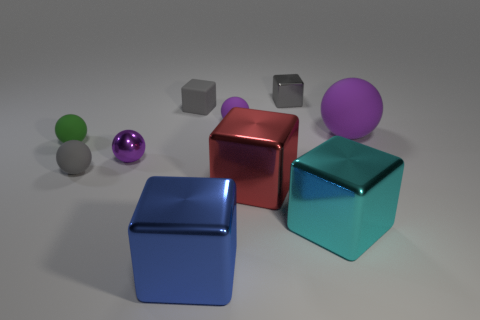Subtract all tiny gray cubes. How many cubes are left? 3 Subtract all gray spheres. How many spheres are left? 4 Subtract all large rubber things. Subtract all matte spheres. How many objects are left? 5 Add 4 tiny rubber cubes. How many tiny rubber cubes are left? 5 Add 3 large blue blocks. How many large blue blocks exist? 4 Subtract 0 brown cylinders. How many objects are left? 10 Subtract 3 spheres. How many spheres are left? 2 Subtract all green blocks. Subtract all blue cylinders. How many blocks are left? 5 Subtract all gray blocks. How many green spheres are left? 1 